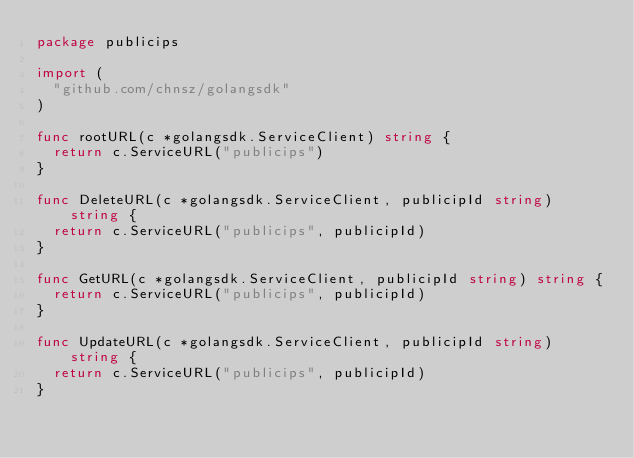<code> <loc_0><loc_0><loc_500><loc_500><_Go_>package publicips

import (
	"github.com/chnsz/golangsdk"
)

func rootURL(c *golangsdk.ServiceClient) string {
	return c.ServiceURL("publicips")
}

func DeleteURL(c *golangsdk.ServiceClient, publicipId string) string {
	return c.ServiceURL("publicips", publicipId)
}

func GetURL(c *golangsdk.ServiceClient, publicipId string) string {
	return c.ServiceURL("publicips", publicipId)
}

func UpdateURL(c *golangsdk.ServiceClient, publicipId string) string {
	return c.ServiceURL("publicips", publicipId)
}
</code> 